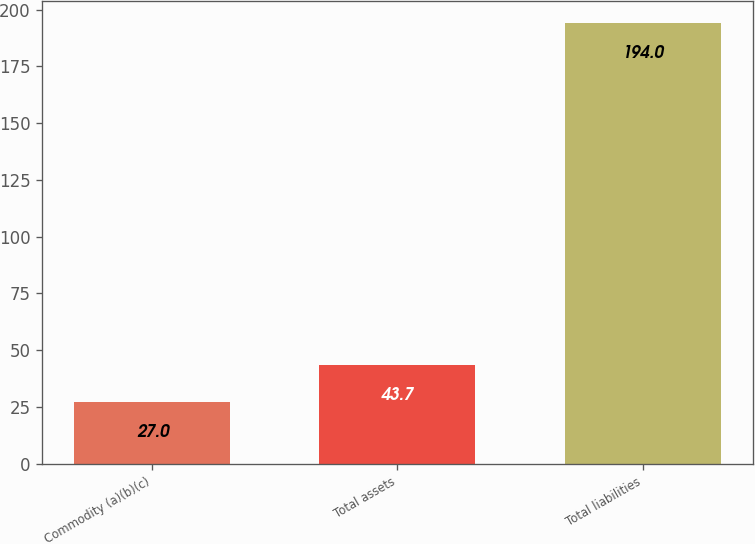Convert chart to OTSL. <chart><loc_0><loc_0><loc_500><loc_500><bar_chart><fcel>Commodity (a)(b)(c)<fcel>Total assets<fcel>Total liabilities<nl><fcel>27<fcel>43.7<fcel>194<nl></chart> 